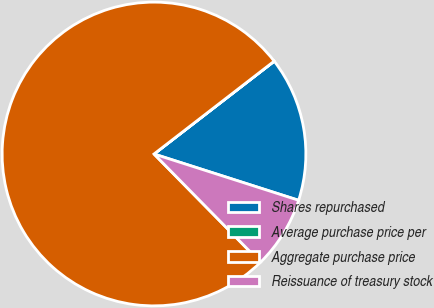Convert chart. <chart><loc_0><loc_0><loc_500><loc_500><pie_chart><fcel>Shares repurchased<fcel>Average purchase price per<fcel>Aggregate purchase price<fcel>Reissuance of treasury stock<nl><fcel>15.39%<fcel>0.01%<fcel>76.89%<fcel>7.7%<nl></chart> 